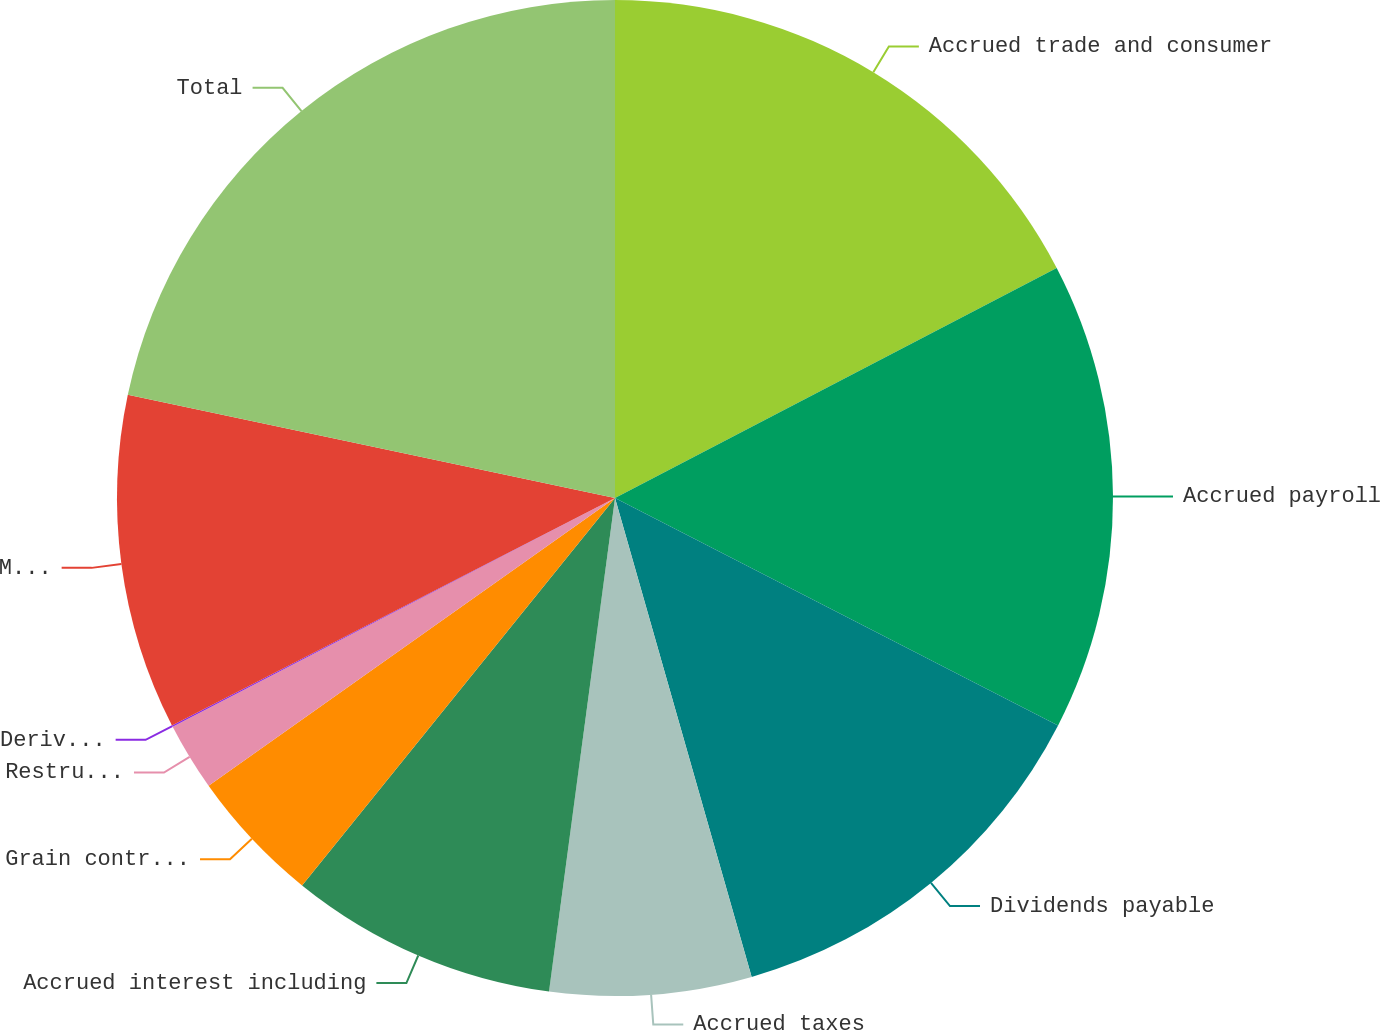<chart> <loc_0><loc_0><loc_500><loc_500><pie_chart><fcel>Accrued trade and consumer<fcel>Accrued payroll<fcel>Dividends payable<fcel>Accrued taxes<fcel>Accrued interest including<fcel>Grain contracts<fcel>Restructuring and other exit<fcel>Derivative payable<fcel>Miscellaneous<fcel>Total<nl><fcel>17.36%<fcel>15.19%<fcel>13.03%<fcel>6.54%<fcel>8.7%<fcel>4.38%<fcel>2.21%<fcel>0.05%<fcel>10.87%<fcel>21.68%<nl></chart> 